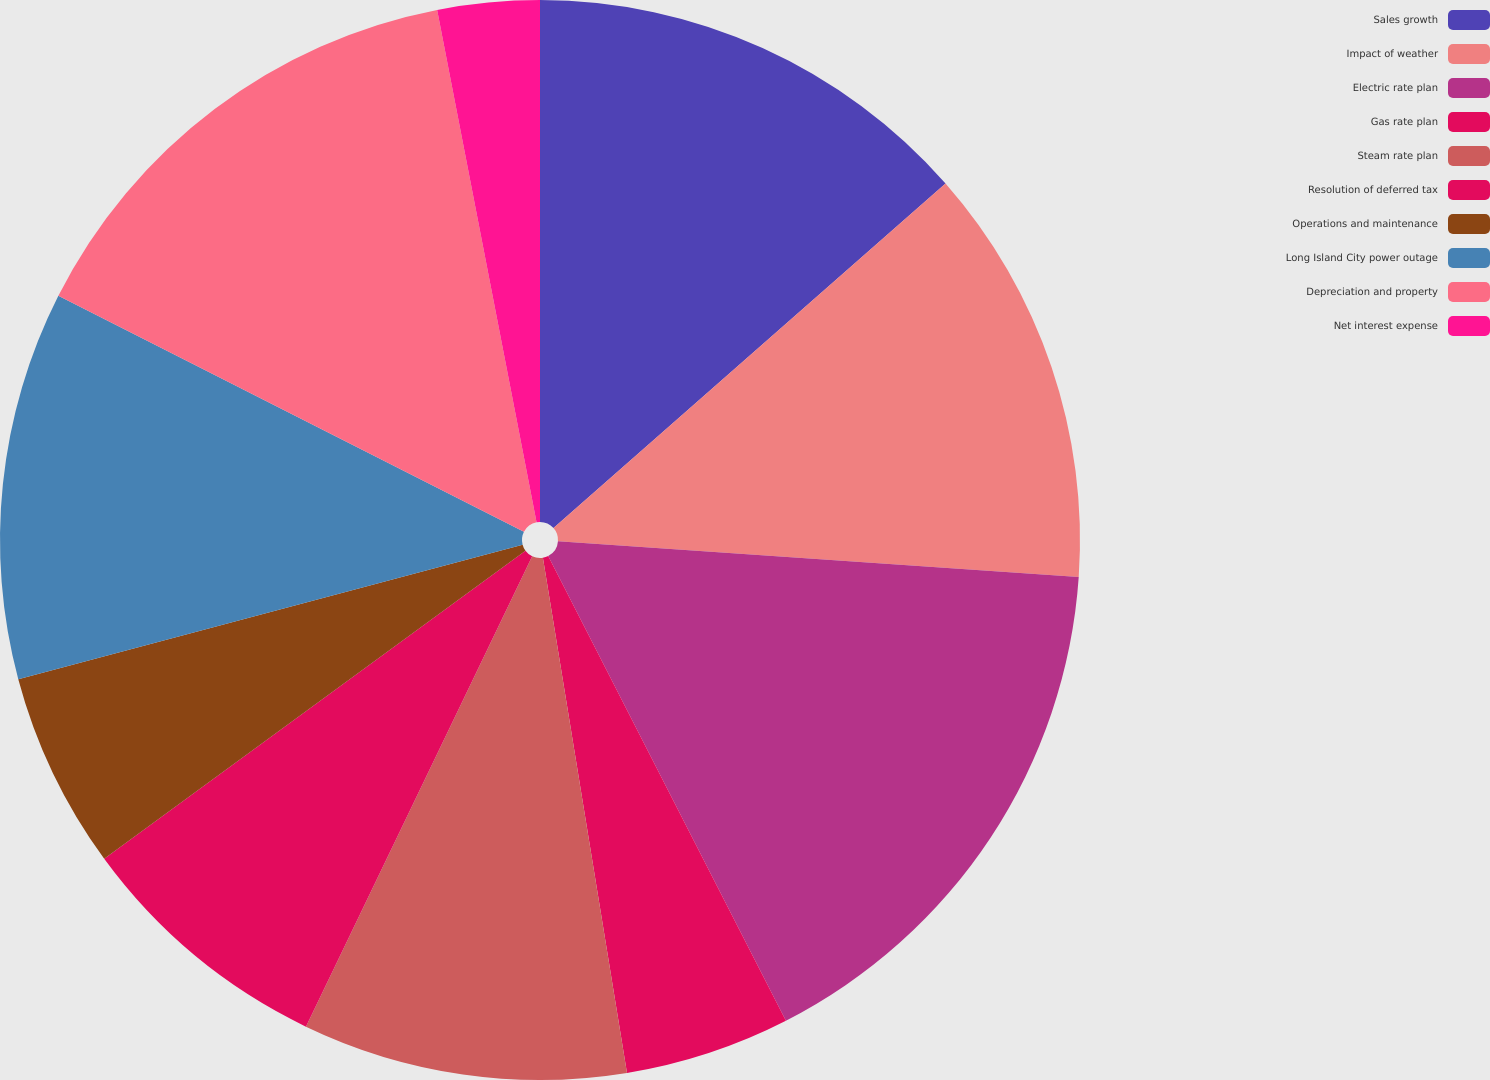Convert chart to OTSL. <chart><loc_0><loc_0><loc_500><loc_500><pie_chart><fcel>Sales growth<fcel>Impact of weather<fcel>Electric rate plan<fcel>Gas rate plan<fcel>Steam rate plan<fcel>Resolution of deferred tax<fcel>Operations and maintenance<fcel>Long Island City power outage<fcel>Depreciation and property<fcel>Net interest expense<nl><fcel>13.52%<fcel>12.57%<fcel>16.38%<fcel>4.95%<fcel>9.71%<fcel>7.81%<fcel>5.9%<fcel>11.62%<fcel>14.48%<fcel>3.05%<nl></chart> 